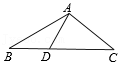Imagine triangle ABC represents a piece of land. How might the characteristics of this triangle affect the division of the land among three parties? The isosceles nature of triangle ABC could represent an equitable distribution of land between two parties, with both receiving plots of the same size and shape, as indicated by the equal lengths AB and AC. The third party, acquiring the base portion, might receive a slightly different shape, but can also be designed to have an equitable area. It's also interesting to note that the altitude from A, which can be considered the line segment AD, divides the land into two symmetrical halves, which is an appealing characteristic from both a design and a functional perspective. 